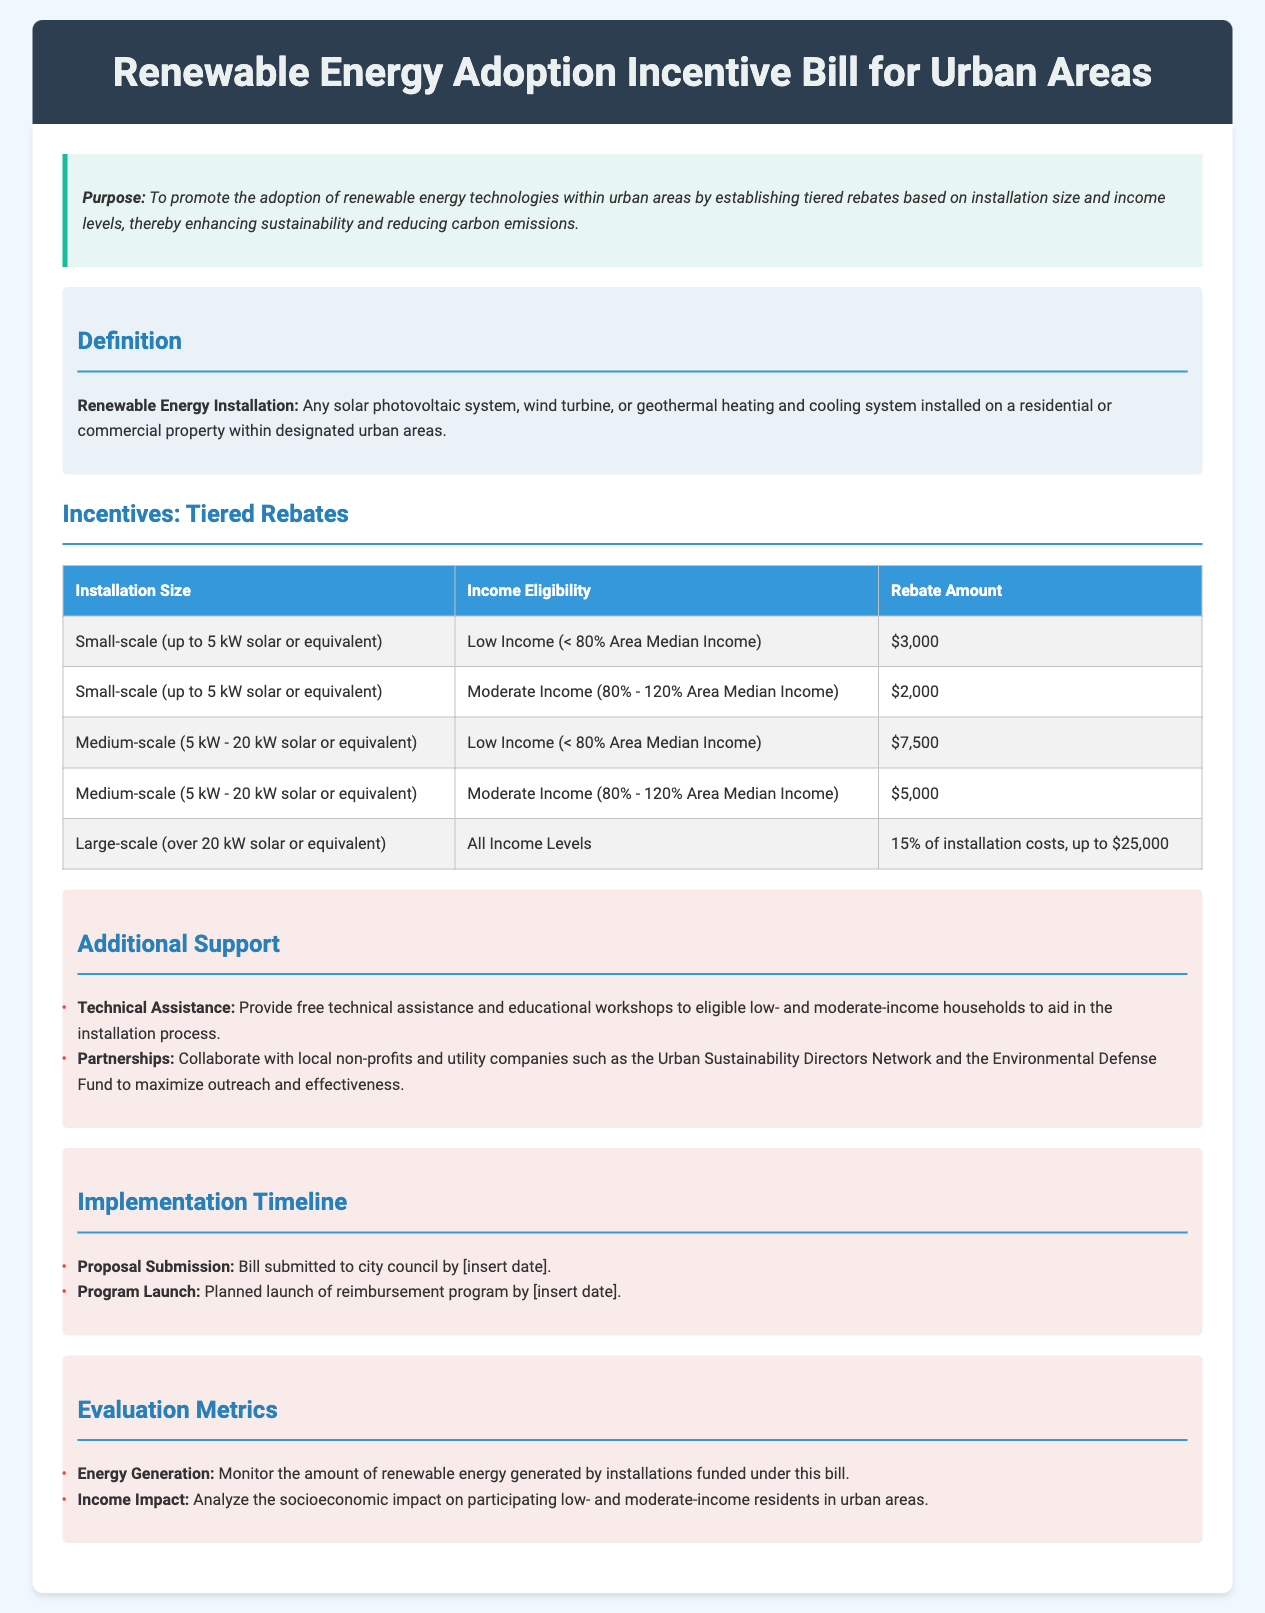What is the purpose of the bill? The purpose is to promote the adoption of renewable energy technologies within urban areas by establishing tiered rebates based on installation size and income levels.
Answer: To promote the adoption of renewable energy technologies What is the rebate amount for low-income small-scale installations? The rebate amount for low-income small-scale installations is clearly stated in the incentives table.
Answer: $3,000 What is the income eligibility for medium-scale installations with a rebate of $7,500? The document specifies that this rebate is for low-income residents, which is defined as earning less than 80% of the Area Median Income.
Answer: Low Income (< 80% Area Median Income) What percentage of installation costs is covered for large-scale installations? The rebate for large-scale installations is defined as a certain percentage of the installation costs in the incentives table.
Answer: 15% of installation costs What additional support is provided to eligible households? The document lists the types of additional support offered, specifically mentioning technical assistance and partnerships.
Answer: Technical Assistance How many metrics are listed for evaluation? The evaluation section describes the specific metrics to measure success, which can be counted directly in the document.
Answer: 2 What title is given to the section defining renewal energy installation? The section is clearly titled in the document, indicating its purpose in defining the key term.
Answer: Definition When is the planned launch of the reimbursement program? The document mentions a placeholder for the launch date of the reimbursement program, indicating a planned schedule.
Answer: [insert date] 